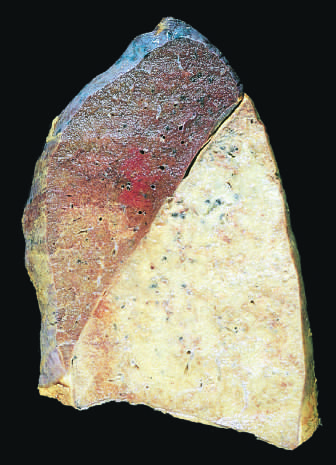s the lower lobe uniformly consolidated?
Answer the question using a single word or phrase. Yes 